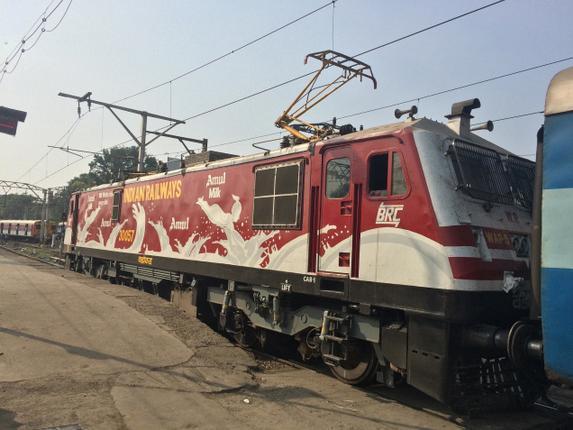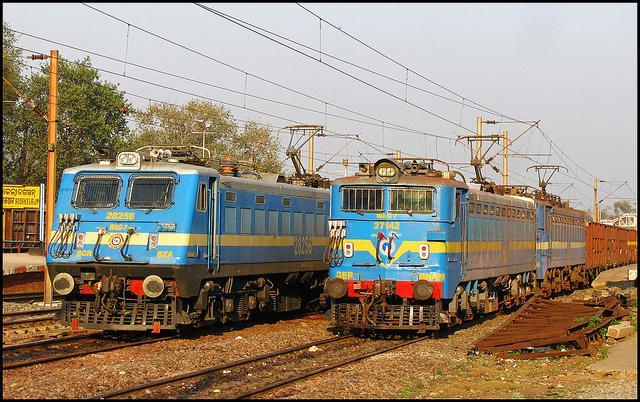The first image is the image on the left, the second image is the image on the right. For the images shown, is this caption "There are two trains in the image on the right." true? Answer yes or no. Yes. 